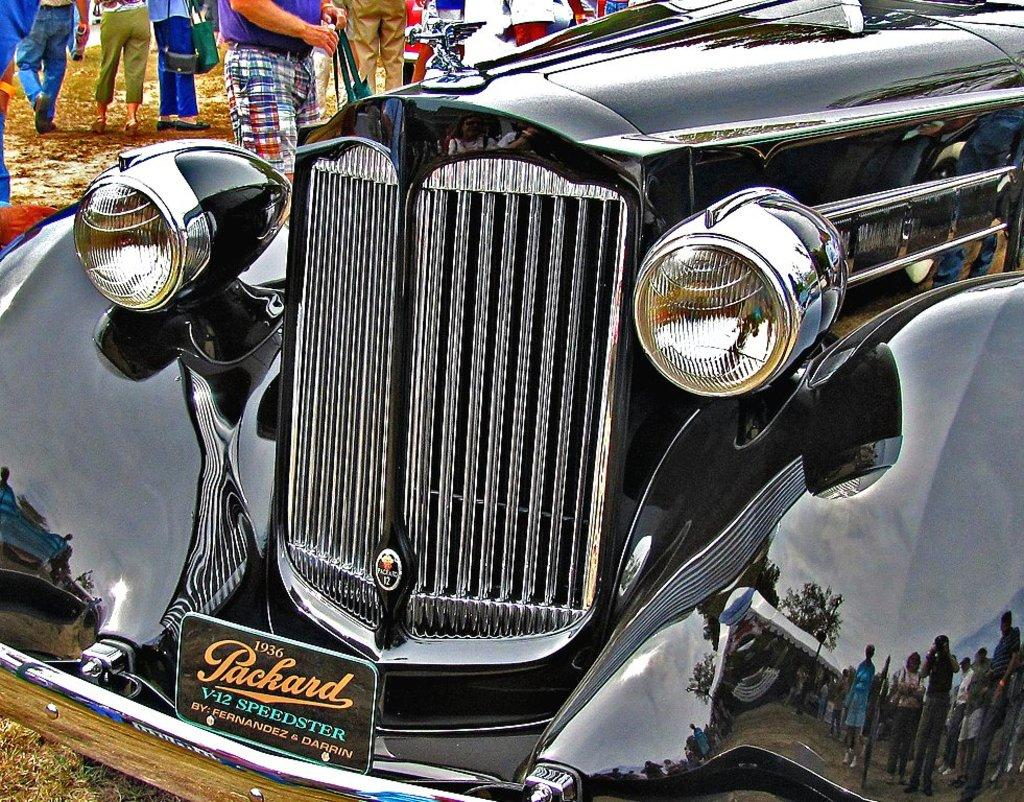How many people are in the image? There are people in the image, but the exact number is not specified. What are some people doing in the image? Some people are holding objects in the image. What type of vehicle is in the image? There is a vehicle in the image, but its specific type is not mentioned. What can be seen on the ground in the image? The ground is visible in the image, and grass is present on it. How many babies are growing in the image? There is no mention of babies or growth in the image; it features people, objects, a vehicle, and a grassy ground. 